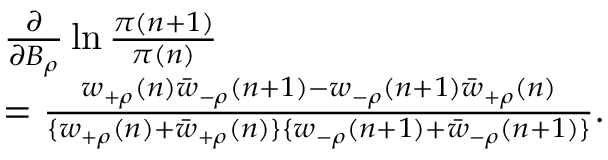<formula> <loc_0><loc_0><loc_500><loc_500>\begin{array} { r l } & { \frac { \partial } { \partial B _ { \rho } } \ln \frac { \pi ( n + 1 ) } { \pi ( n ) } \ } \\ & { = \frac { w _ { + \rho } ( n ) \bar { w } _ { - \rho } ( n + 1 ) - w _ { - \rho } ( n + 1 ) \bar { w } _ { + \rho } ( n ) } { \{ w _ { + \rho } ( n ) + \bar { w } _ { + \rho } ( n ) \} \{ w _ { - \rho } ( n + 1 ) + \bar { w } _ { - \rho } ( n + 1 ) \} } . } \end{array}</formula> 